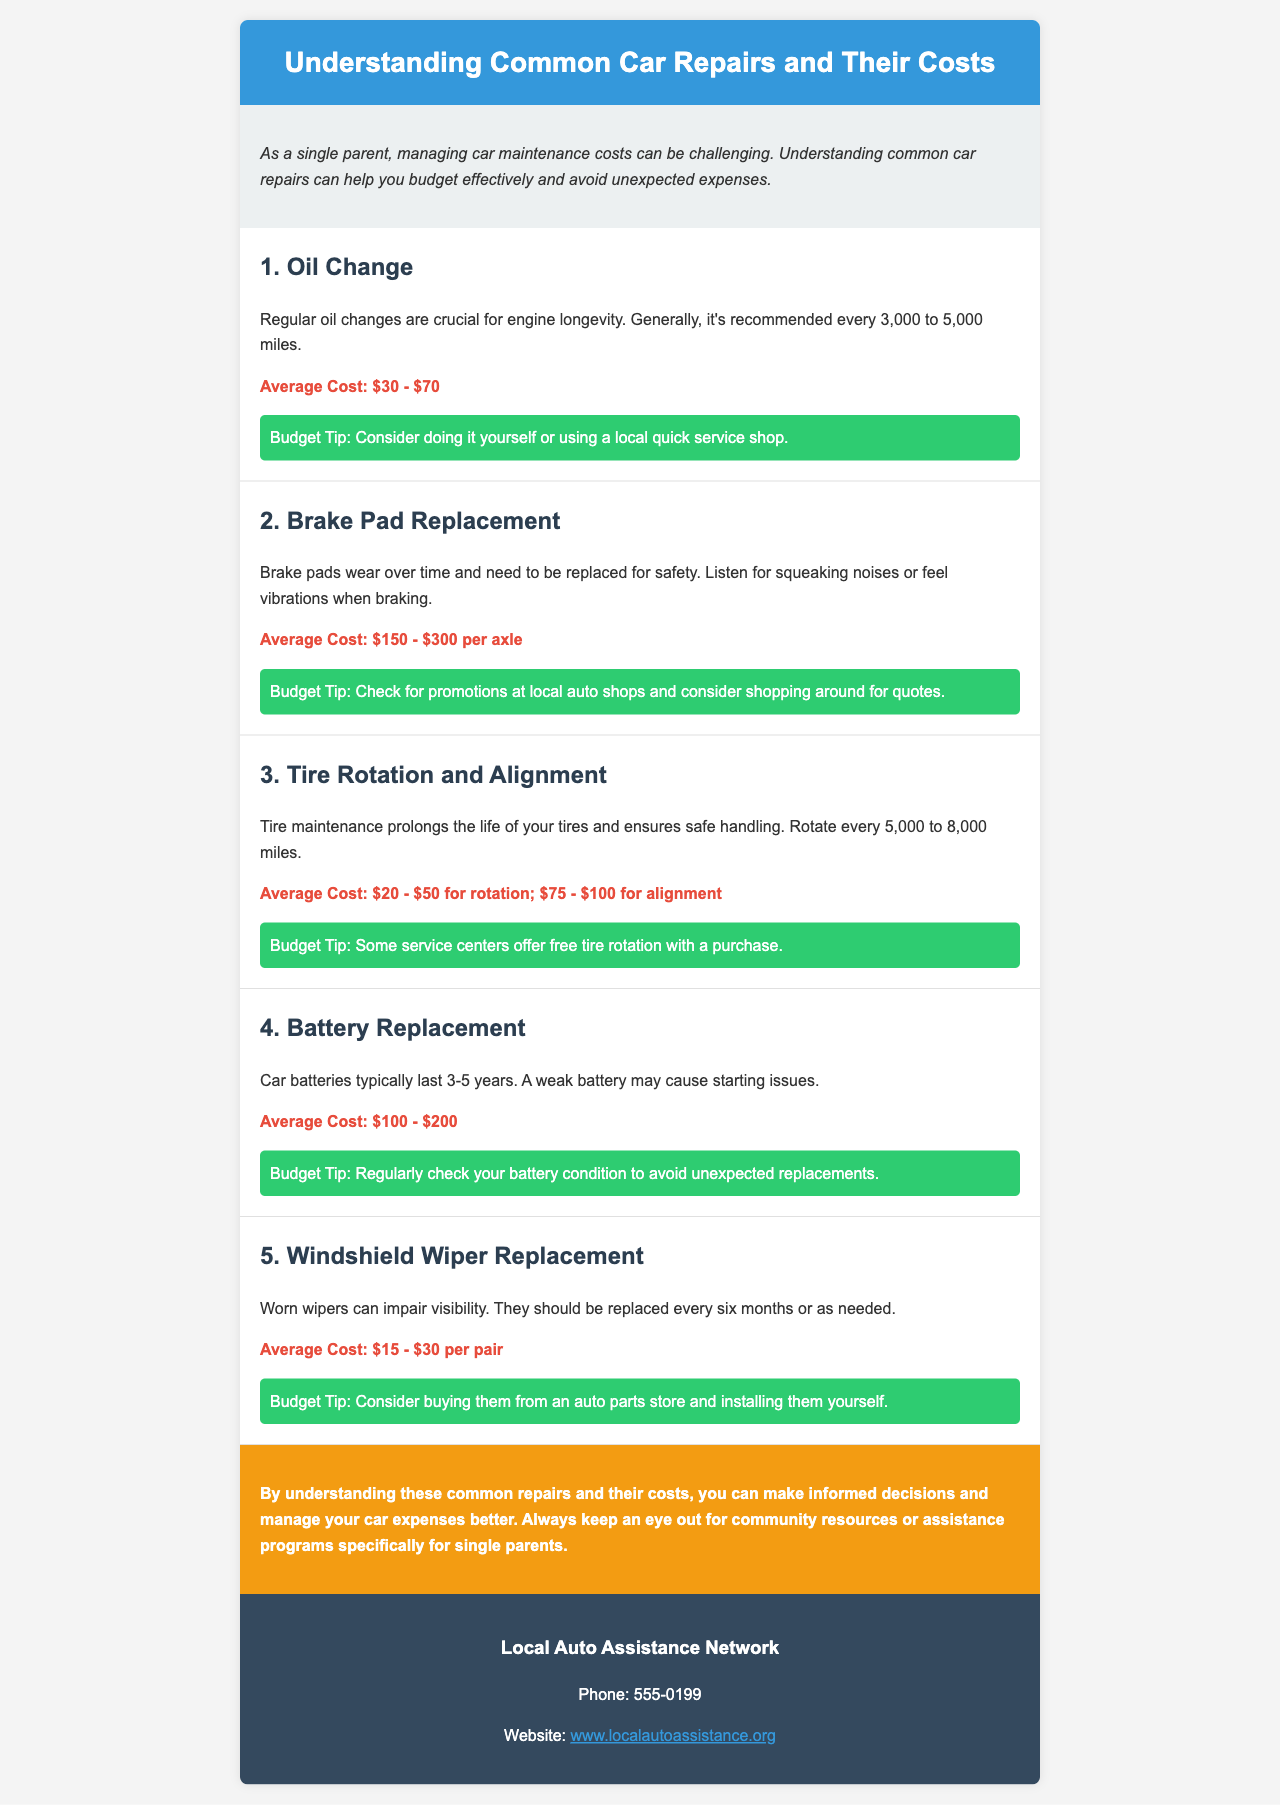What is the average cost of an oil change? The average cost of an oil change is mentioned in the document.
Answer: $30 - $70 How often should you do a tire rotation? The document specifies the recommended interval for tire rotation.
Answer: Every 5,000 to 8,000 miles What can indicate that brake pads need replacement? The document lists signs that brake pads have worn out.
Answer: Squeaking noises or vibrations What is the cost range for battery replacement? The document states the average cost for replacing a battery.
Answer: $100 - $200 Which repair has the lowest average cost? By comparing the average costs mentioned, this repair can be identified.
Answer: Windshield wiper replacement How many years do car batteries typically last? The document provides a lifespan for car batteries.
Answer: 3-5 years What type of shop is suggested for an oil change budget tip? The budget tip related to oil changes mentions a specific type of service shop.
Answer: Local quick service shop What should you do to avoid unexpected battery replacements? The document advises checking certain conditions to prevent surprises.
Answer: Regularly check your battery condition What is the contact phone number for the Local Auto Assistance Network? The contact information included in the document provides this number.
Answer: 555-0199 